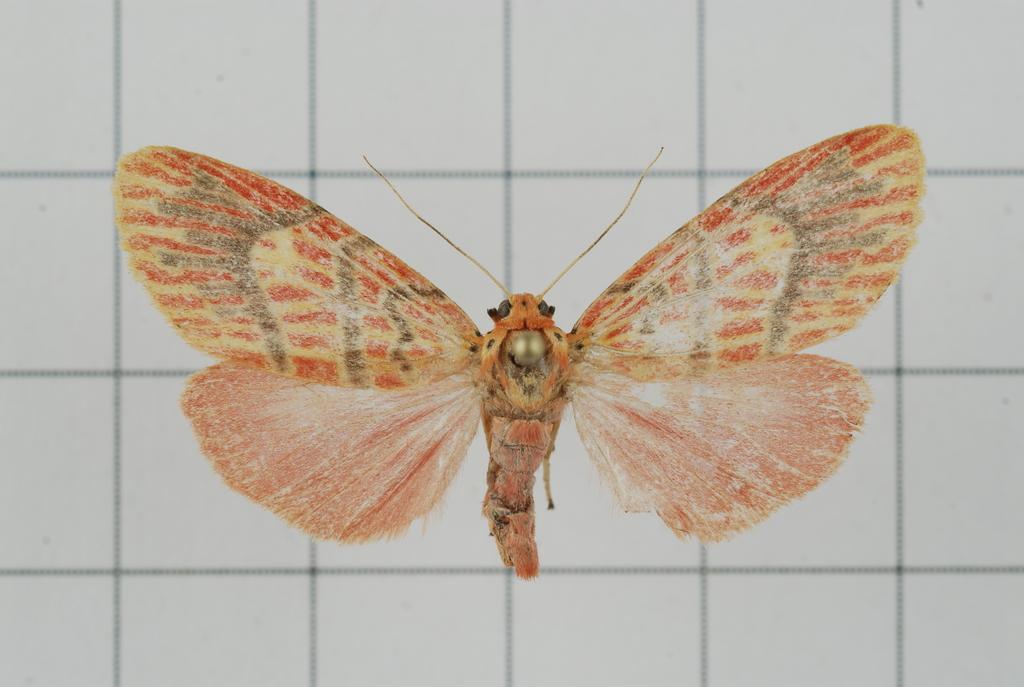How would you summarize this image in a sentence or two? In this picture I can see a butterfly, and in the background there is a wall. 